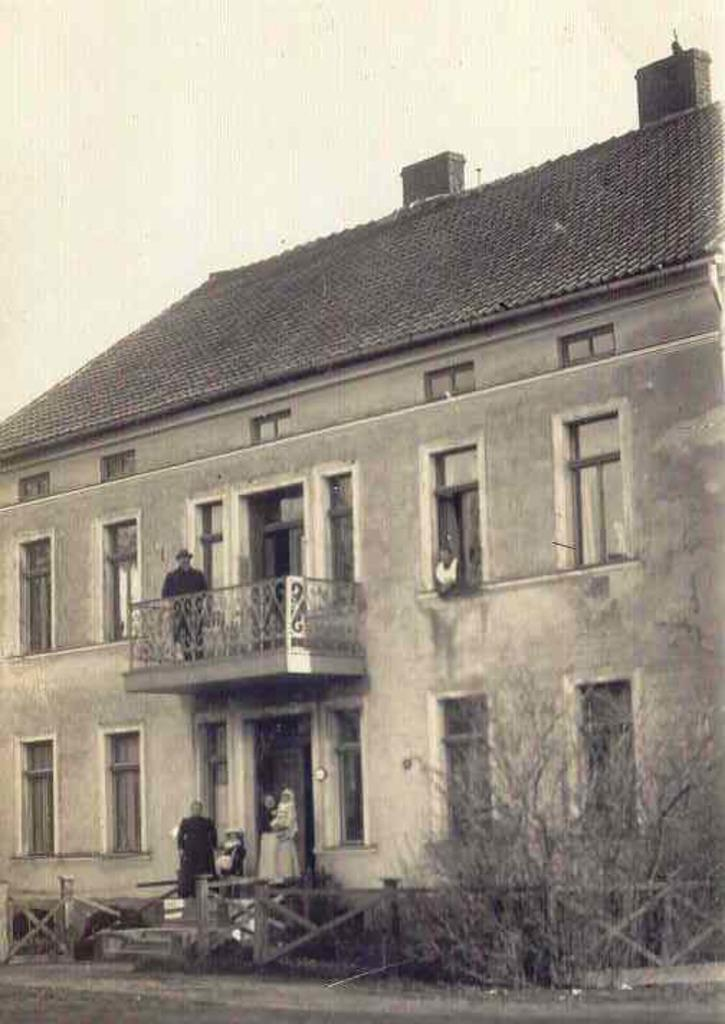What type of structure is present in the image? There is a building in the image. Are there any people visible in the image? Yes, there are people standing in the image. Can you describe the person in the window of the building? A person is peeking out from a window in the building. What is the weather like in the image? The sky is cloudy in the image. What type of natural elements can be seen in the image? There are trees visible in the image. What type of education is being provided in the prison depicted in the image? There is no prison present in the image, and therefore no education being provided. 